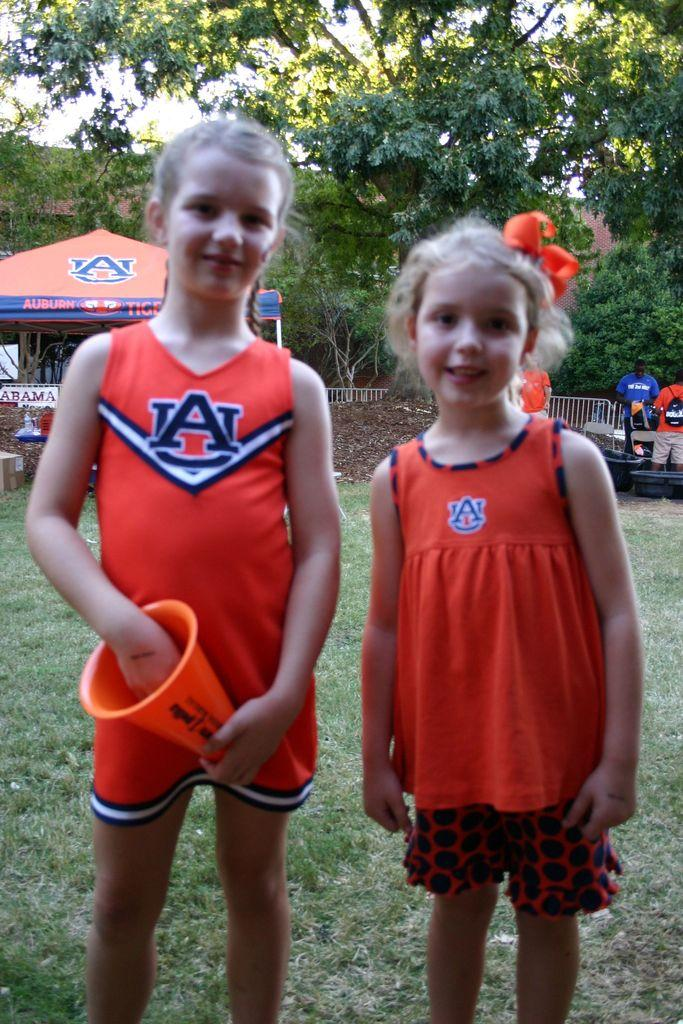<image>
Relay a brief, clear account of the picture shown. Two young girls wearing UA shirts standing in front of a tent. 